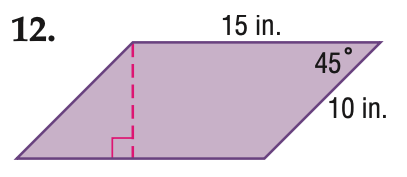Answer the mathemtical geometry problem and directly provide the correct option letter.
Question: Find the perimeter of the parallelogram. Round to the nearest tenth if necessary.
Choices: A: 25 B: 30 C: 40 D: 50 D 